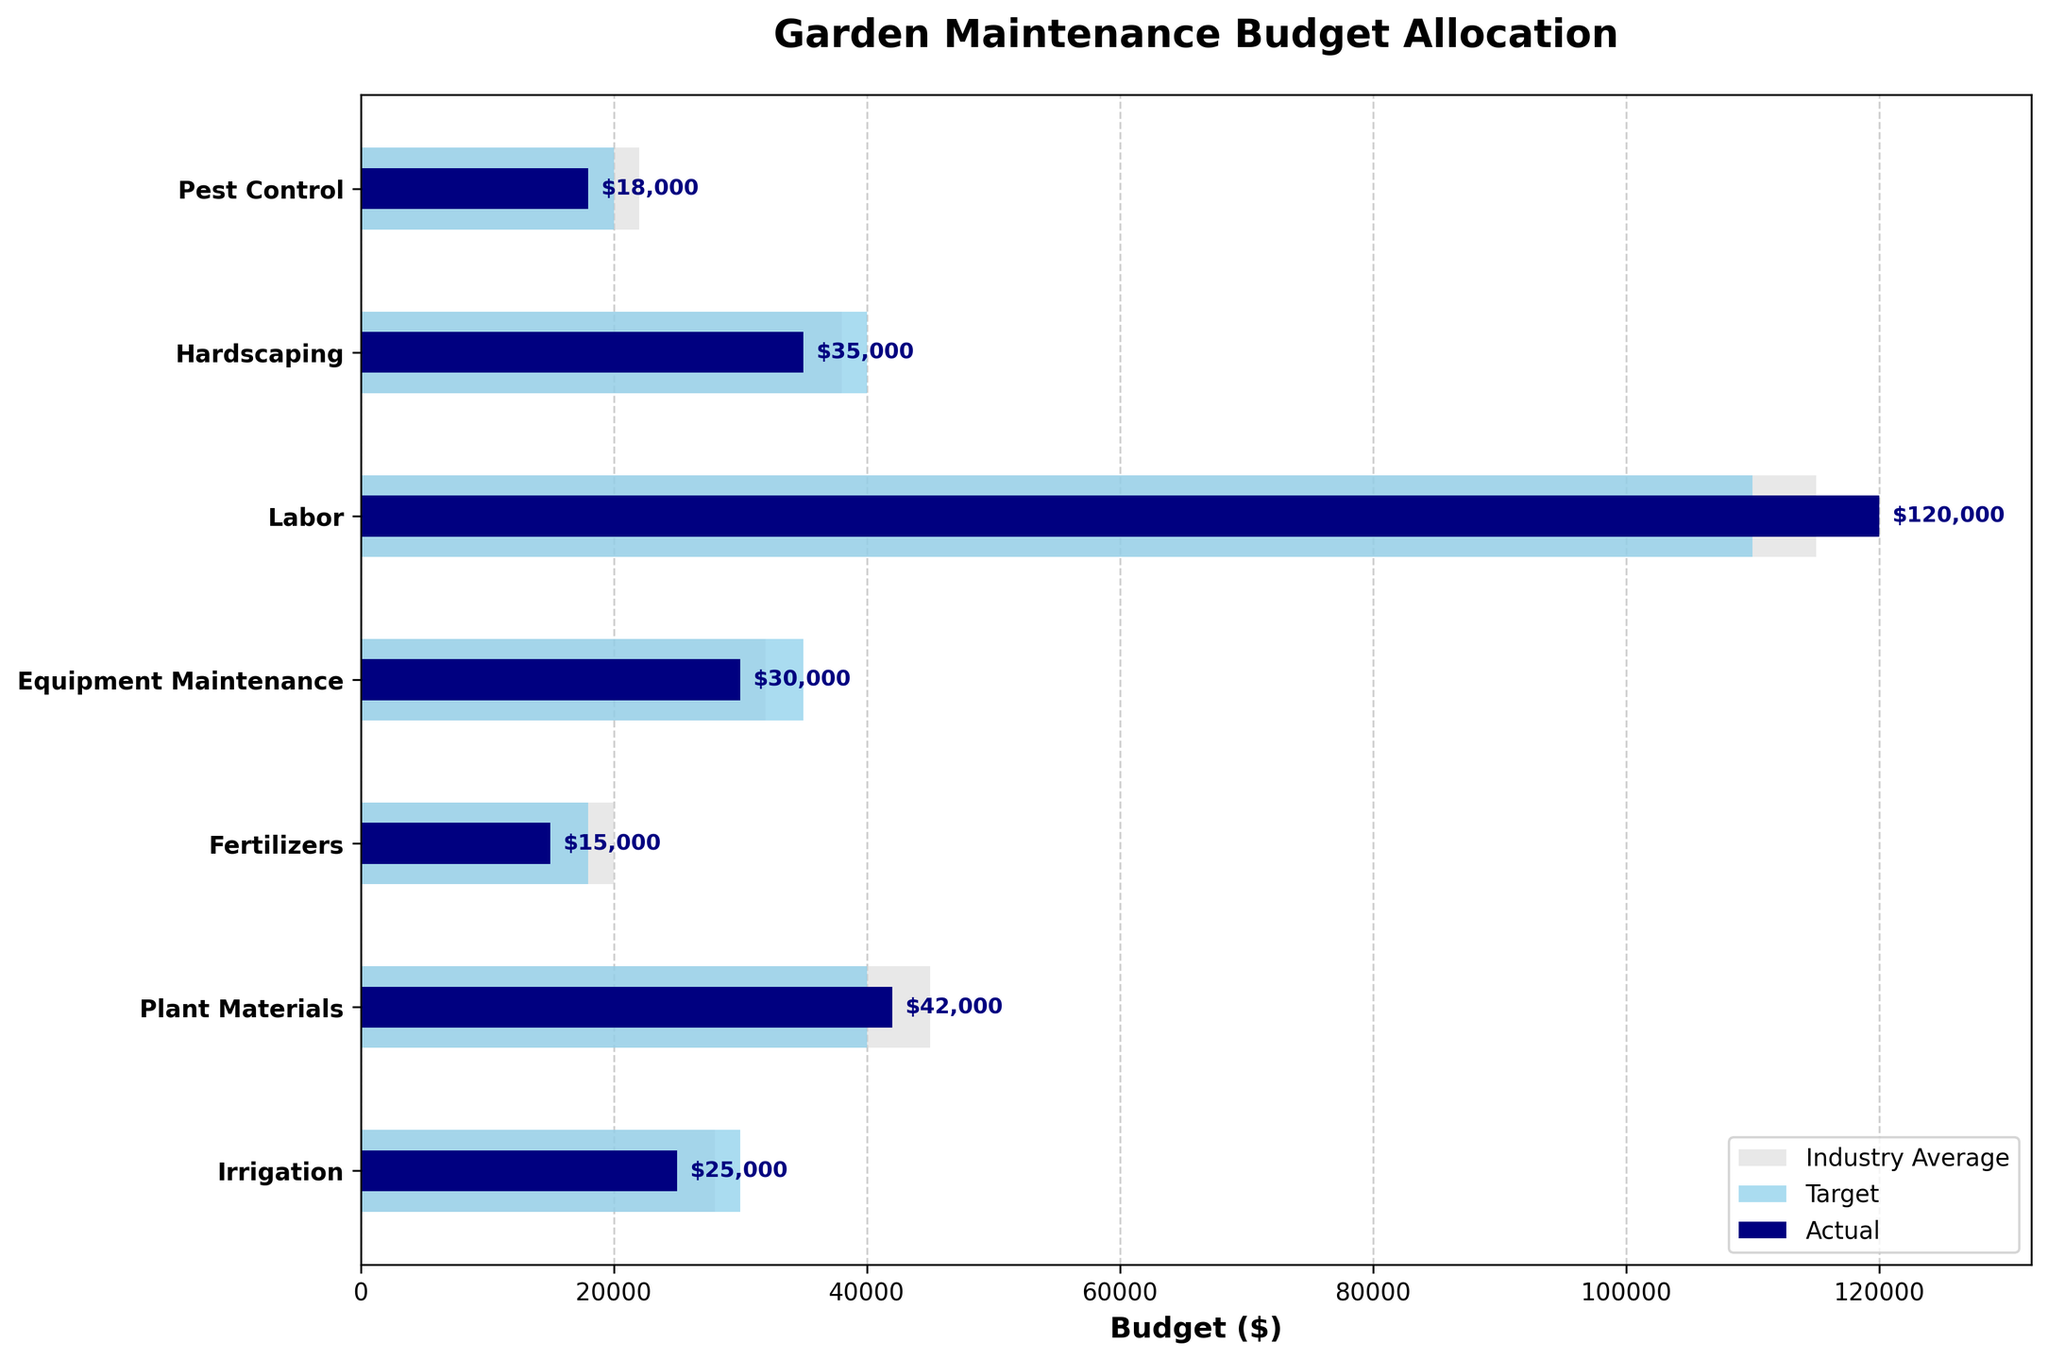How many categories are presented in the chart? Check the number of y-ticks, representing categories, on the y-axis. There are 7 y-ticks, therefore 7 categories.
Answer: 7 What is the title of the chart? The title is shown at the top of the chart. It is "Garden Maintenance Budget Allocation".
Answer: Garden Maintenance Budget Allocation Which category has the highest actual budget? Compare the lengths of the navy bars (actual budget) for each category. The longest navy bar is for "Labor".
Answer: Labor By how much does the actual budget for Irrigation fall short of the target? Subtract the actual budget of Irrigation from its target (30000 - 25000).
Answer: 5000 What is the target budget for Hardscaping? Look at the skyblue bar (target budget) for the Hardscaping category; it extends to 40000.
Answer: 40000 Which coloring is used for the industry average in the plot? Industry average bars are distinctly colored light gray, as labeled in the legend.
Answer: Light gray Which categories meet or exceed their target budget? Compare the lengths of the navy and skyblue bars. "Plant Materials" and "Labor" have actual budgets meeting or exceeding their targets.
Answer: Plant Materials, Labor What’s the difference between the actual and industry average budget for Fertilizers? Subtract the actual budget of Fertilizers from its industry average (20000 - 15000).
Answer: 5000 How does the actual budget for Equipment Maintenance compare to the industry average? The navy bar (actual) for Equipment Maintenance is shorter than the light gray bar (industry average), indicating the actual budget is less.
Answer: Less In which category is the actual budget closest to the industry average? Compare the lengths of the navy (actual) and light gray (industry average) bars. The closest match is for "Labor".
Answer: Labor 